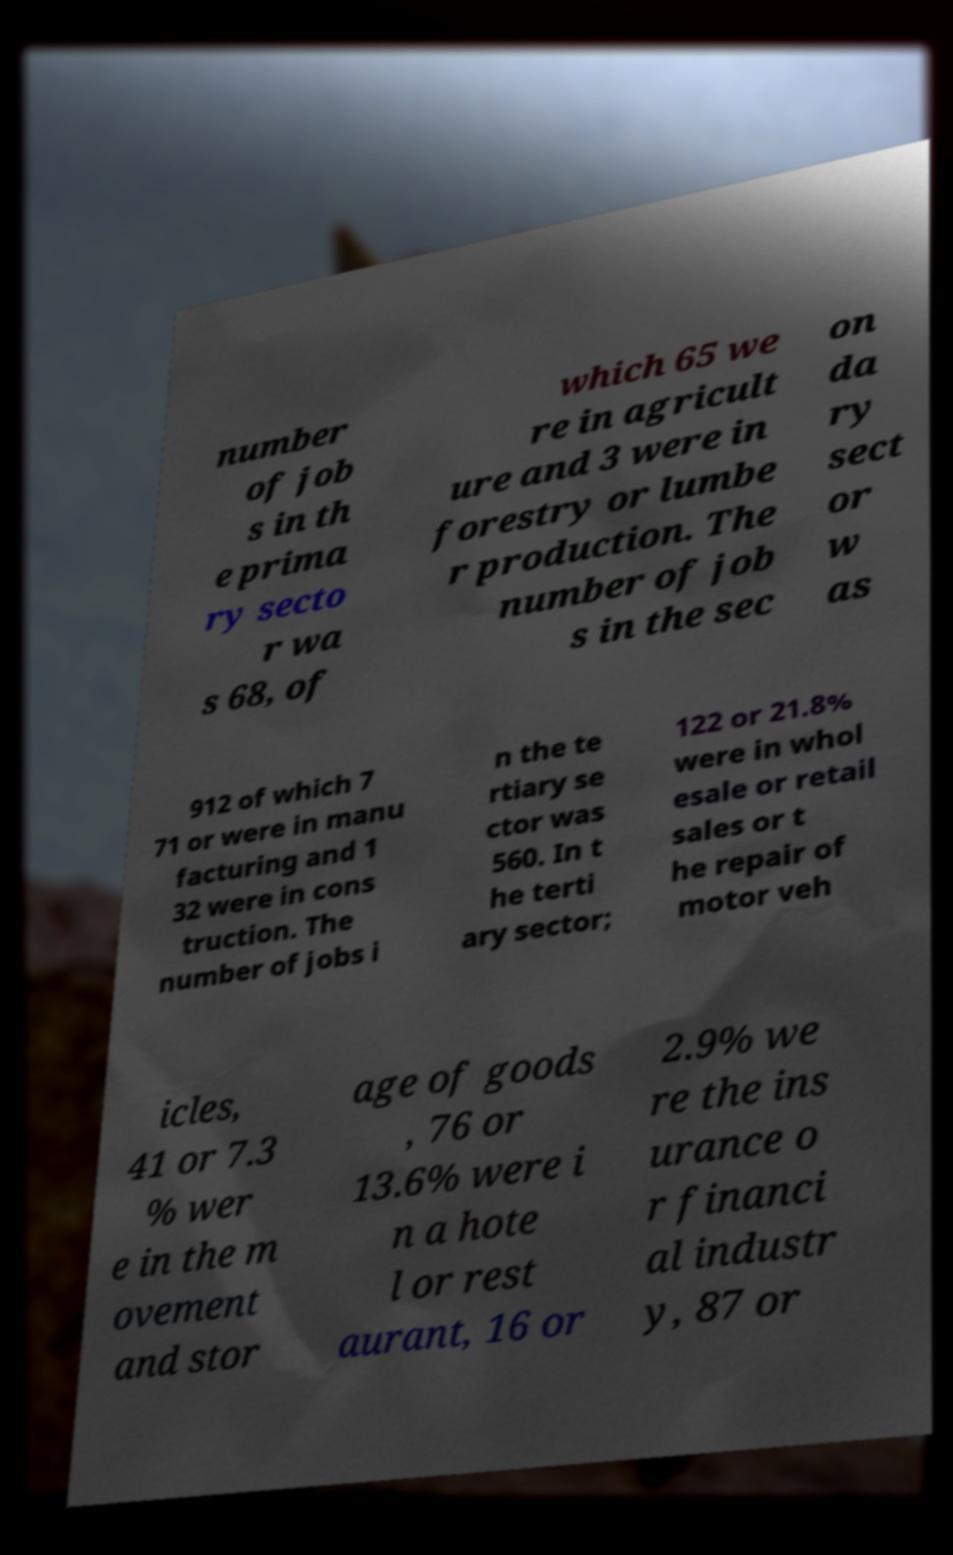Please identify and transcribe the text found in this image. number of job s in th e prima ry secto r wa s 68, of which 65 we re in agricult ure and 3 were in forestry or lumbe r production. The number of job s in the sec on da ry sect or w as 912 of which 7 71 or were in manu facturing and 1 32 were in cons truction. The number of jobs i n the te rtiary se ctor was 560. In t he terti ary sector; 122 or 21.8% were in whol esale or retail sales or t he repair of motor veh icles, 41 or 7.3 % wer e in the m ovement and stor age of goods , 76 or 13.6% were i n a hote l or rest aurant, 16 or 2.9% we re the ins urance o r financi al industr y, 87 or 